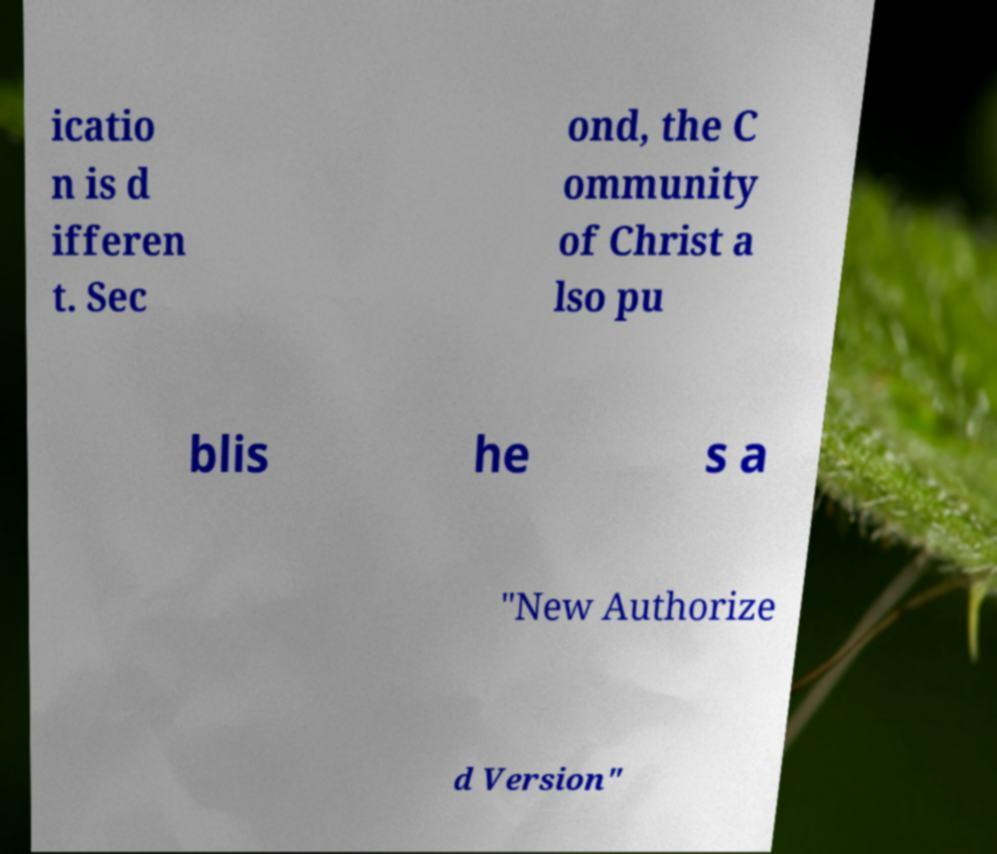There's text embedded in this image that I need extracted. Can you transcribe it verbatim? icatio n is d ifferen t. Sec ond, the C ommunity of Christ a lso pu blis he s a "New Authorize d Version" 